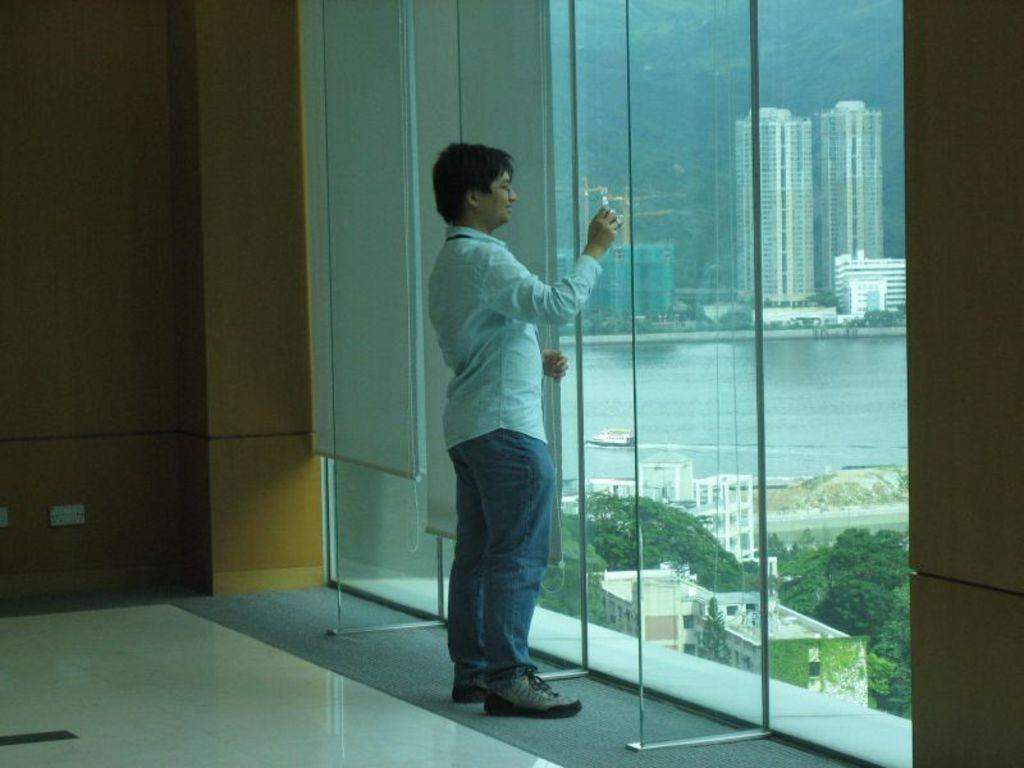What can be seen in the background of the image? There is a wall in the image. Can you describe the man in the image? There is a man wearing a white shirt in the image. What is visible outside the window in the image? Trees, water, a boat, and buildings are visible outside the window. How many girls are visible in the image? There are no girls present in the image. What color is the man's chin in the image? The man's chin is not mentioned in the provided facts, and therefore we cannot determine its color. 